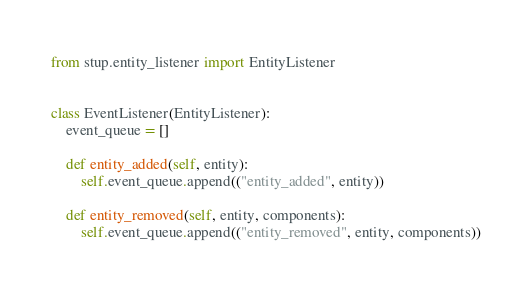Convert code to text. <code><loc_0><loc_0><loc_500><loc_500><_Python_>from stup.entity_listener import EntityListener


class EventListener(EntityListener):
    event_queue = []

    def entity_added(self, entity):
        self.event_queue.append(("entity_added", entity))

    def entity_removed(self, entity, components):
        self.event_queue.append(("entity_removed", entity, components))
</code> 